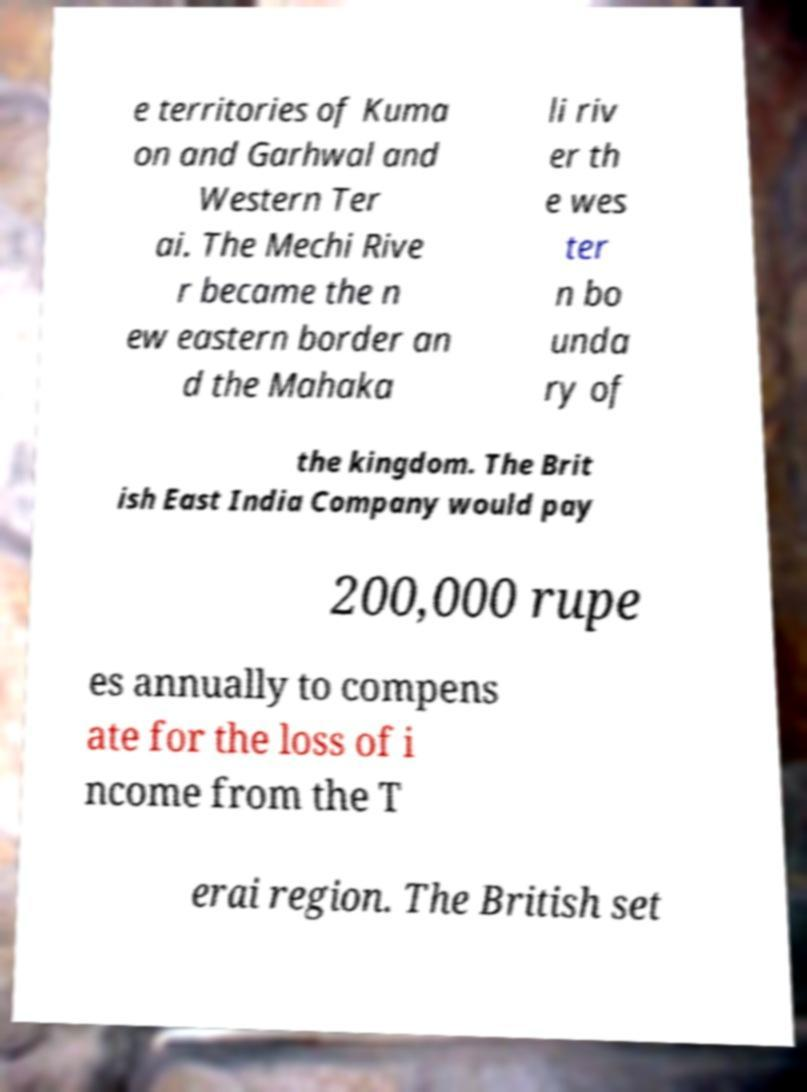Please read and relay the text visible in this image. What does it say? e territories of Kuma on and Garhwal and Western Ter ai. The Mechi Rive r became the n ew eastern border an d the Mahaka li riv er th e wes ter n bo unda ry of the kingdom. The Brit ish East India Company would pay 200,000 rupe es annually to compens ate for the loss of i ncome from the T erai region. The British set 